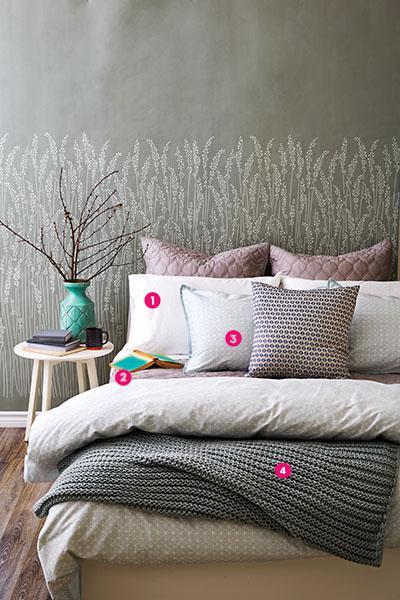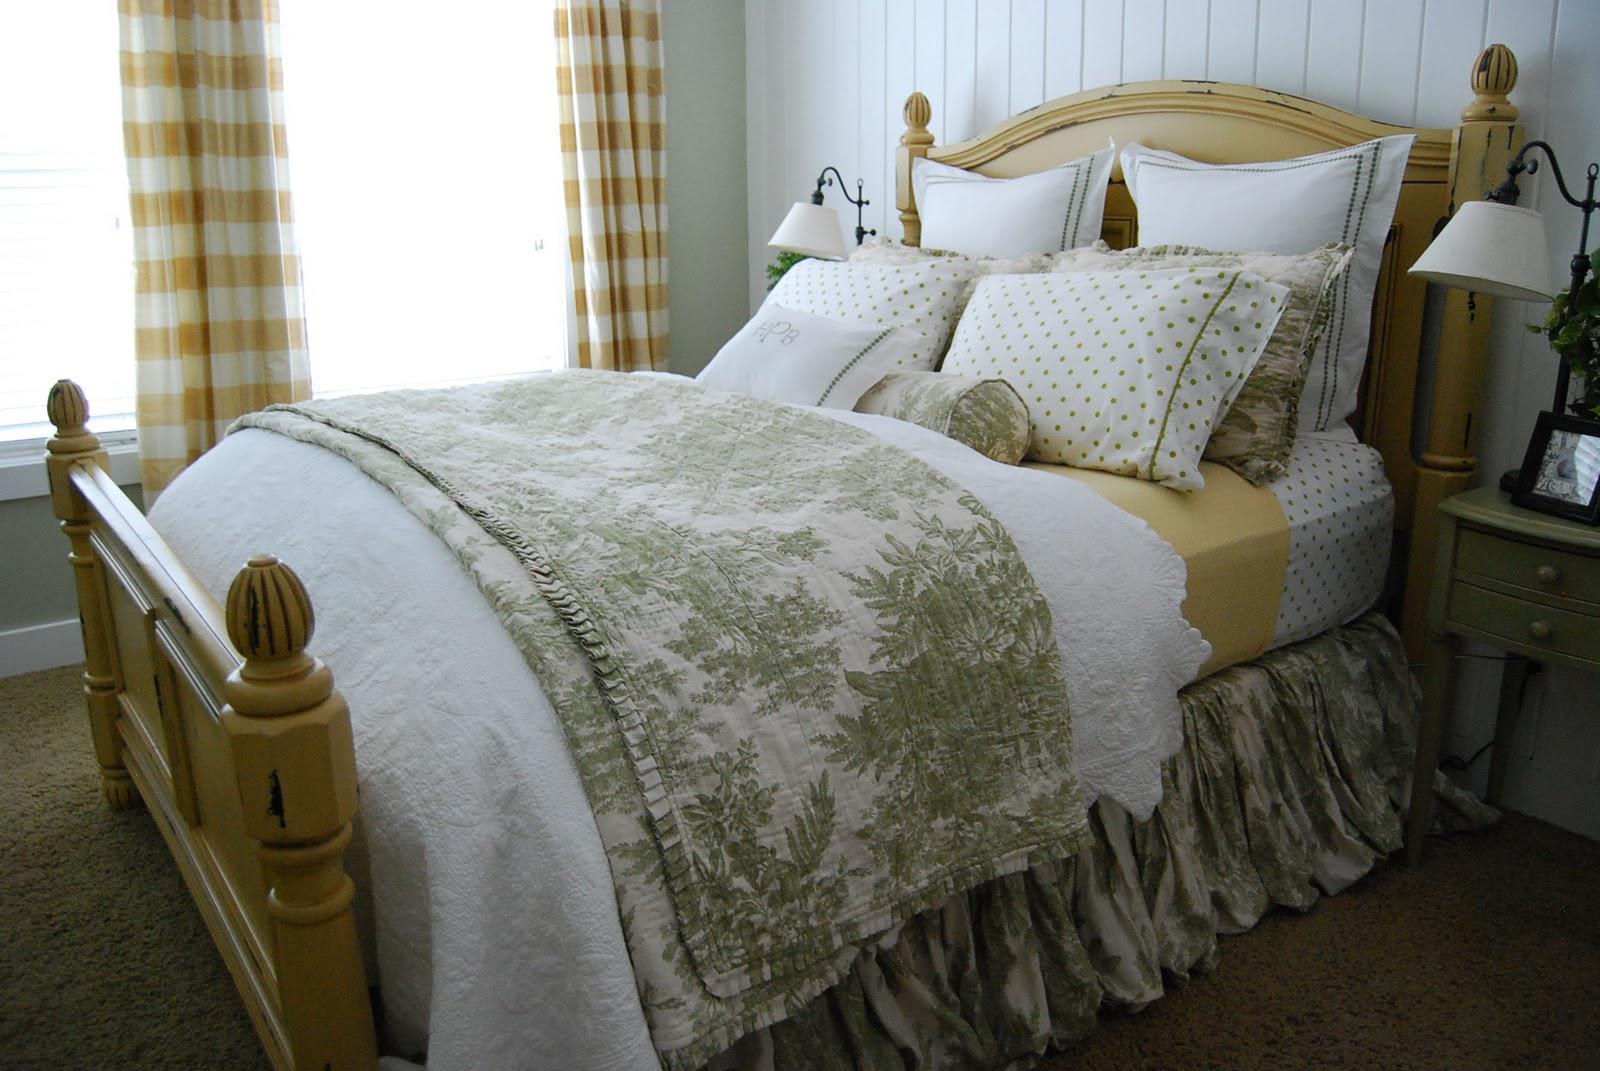The first image is the image on the left, the second image is the image on the right. Assess this claim about the two images: "An image of a bedroom features bare branches somewhere in the decor.". Correct or not? Answer yes or no. Yes. The first image is the image on the left, the second image is the image on the right. For the images shown, is this caption "There are lamps on each side of a bed" true? Answer yes or no. Yes. 